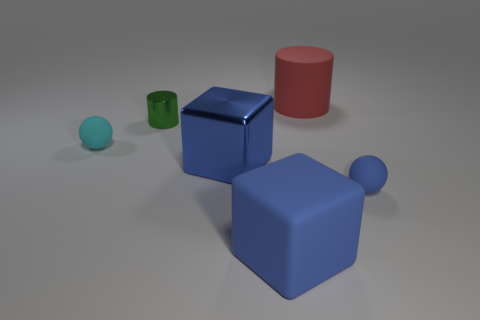Add 3 large blue matte cubes. How many objects exist? 9 Add 2 green shiny cylinders. How many green shiny cylinders exist? 3 Subtract 0 blue cylinders. How many objects are left? 6 Subtract all blocks. How many objects are left? 4 Subtract all purple spheres. Subtract all brown cubes. How many spheres are left? 2 Subtract all tiny blue rubber cubes. Subtract all rubber blocks. How many objects are left? 5 Add 2 cylinders. How many cylinders are left? 4 